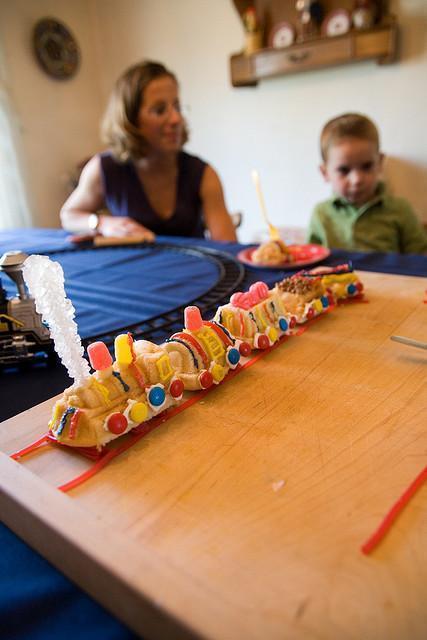How many people can you see?
Give a very brief answer. 2. How many cakes are there?
Give a very brief answer. 3. How many cars are parked?
Give a very brief answer. 0. 